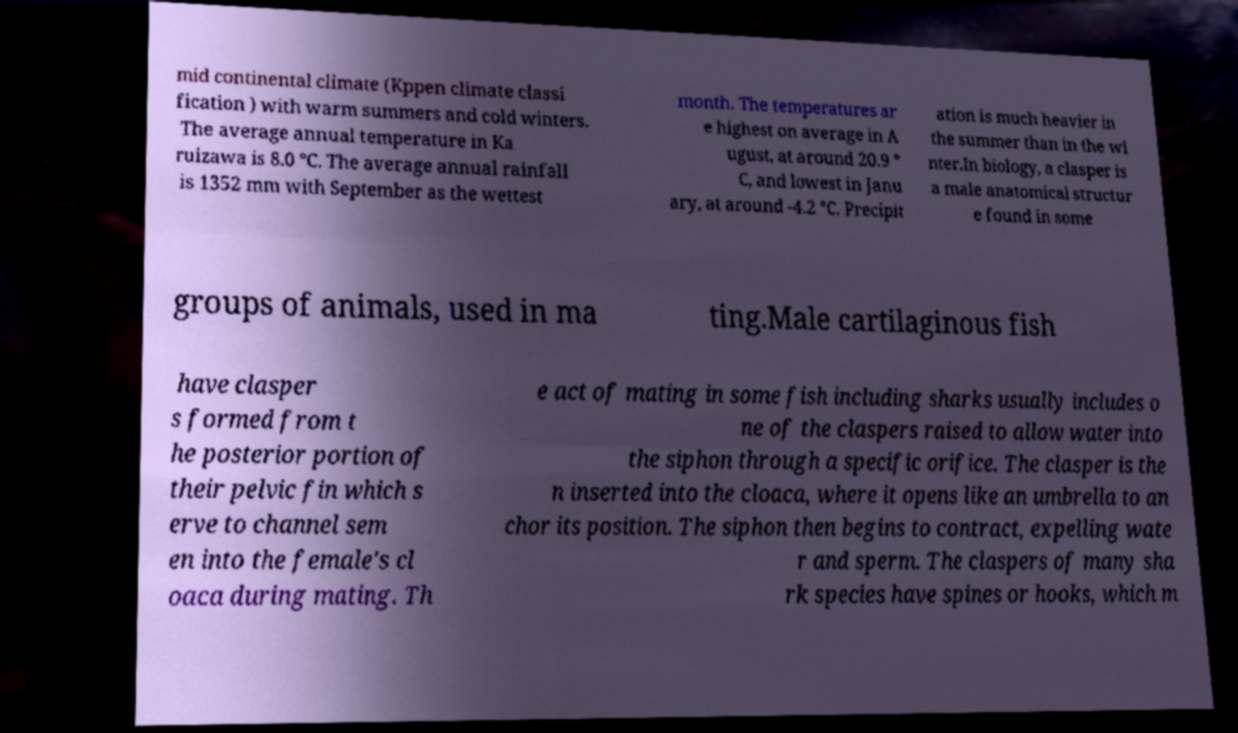There's text embedded in this image that I need extracted. Can you transcribe it verbatim? mid continental climate (Kppen climate classi fication ) with warm summers and cold winters. The average annual temperature in Ka ruizawa is 8.0 °C. The average annual rainfall is 1352 mm with September as the wettest month. The temperatures ar e highest on average in A ugust, at around 20.9 ° C, and lowest in Janu ary, at around -4.2 °C. Precipit ation is much heavier in the summer than in the wi nter.In biology, a clasper is a male anatomical structur e found in some groups of animals, used in ma ting.Male cartilaginous fish have clasper s formed from t he posterior portion of their pelvic fin which s erve to channel sem en into the female's cl oaca during mating. Th e act of mating in some fish including sharks usually includes o ne of the claspers raised to allow water into the siphon through a specific orifice. The clasper is the n inserted into the cloaca, where it opens like an umbrella to an chor its position. The siphon then begins to contract, expelling wate r and sperm. The claspers of many sha rk species have spines or hooks, which m 